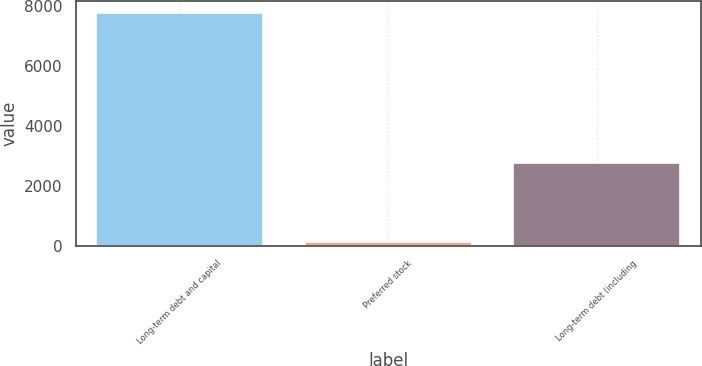Convert chart. <chart><loc_0><loc_0><loc_500><loc_500><bar_chart><fcel>Long-term debt and capital<fcel>Preferred stock<fcel>Long-term debt (including<nl><fcel>7772<fcel>131<fcel>2765<nl></chart> 